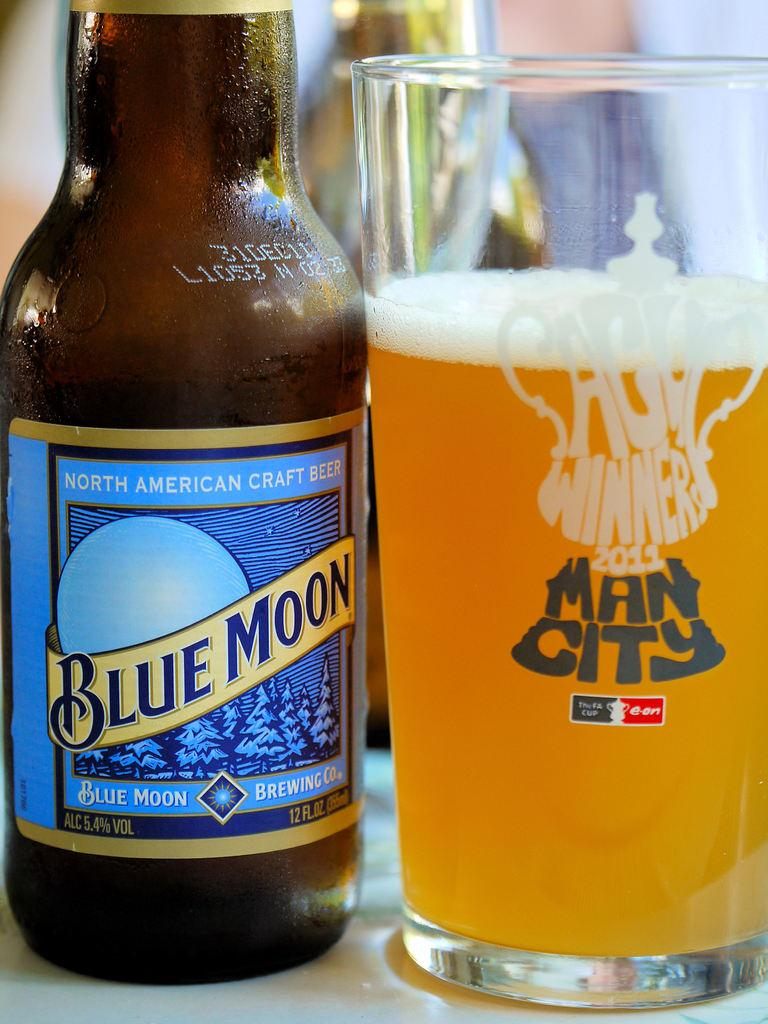<image>
Describe the image concisely. Blue Moon beer bottle next to a cup of beer that says Man City. 